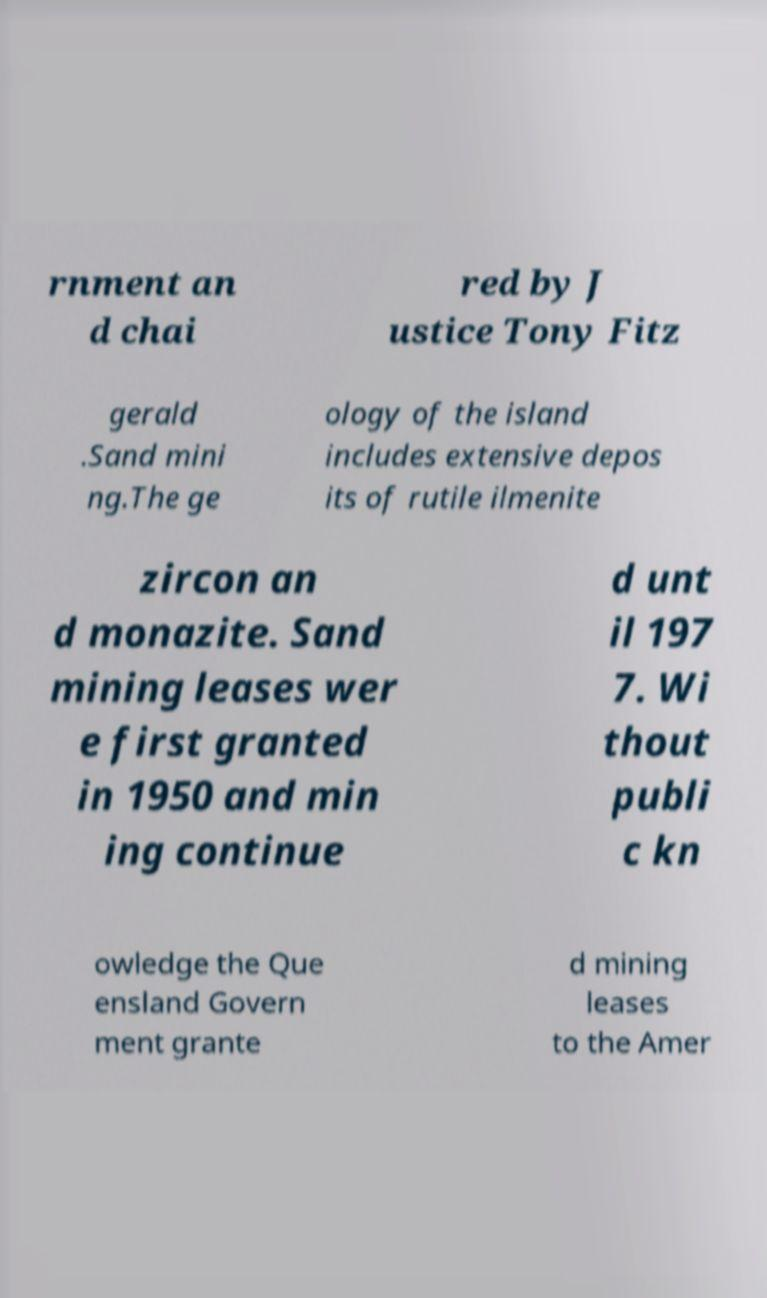Could you extract and type out the text from this image? rnment an d chai red by J ustice Tony Fitz gerald .Sand mini ng.The ge ology of the island includes extensive depos its of rutile ilmenite zircon an d monazite. Sand mining leases wer e first granted in 1950 and min ing continue d unt il 197 7. Wi thout publi c kn owledge the Que ensland Govern ment grante d mining leases to the Amer 